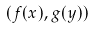<formula> <loc_0><loc_0><loc_500><loc_500>( f ( x ) , g ( y ) )</formula> 